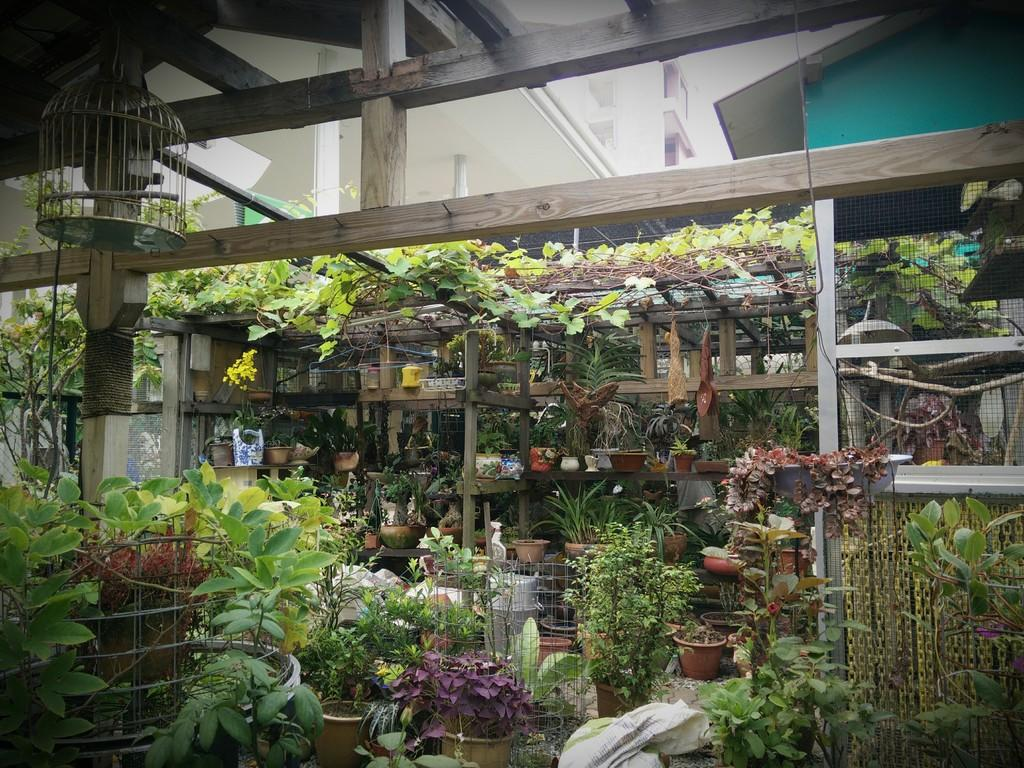What type of containers are visible in the image? There are plant pots in the image. What is inside the containers? There are plants inside the containers. What type of furniture is present in the image? There are wooden shelves in the image. What type of enclosure is visible in the image? There is a bird cage in the image. What other objects can be seen in the image? There are other objects in the image, but their specific details are not mentioned in the provided facts. How many cows are visible in the image? There are no cows present in the image. What color is the tail of the bird in the bird cage? There is no information about the bird or its tail color in the provided facts. 